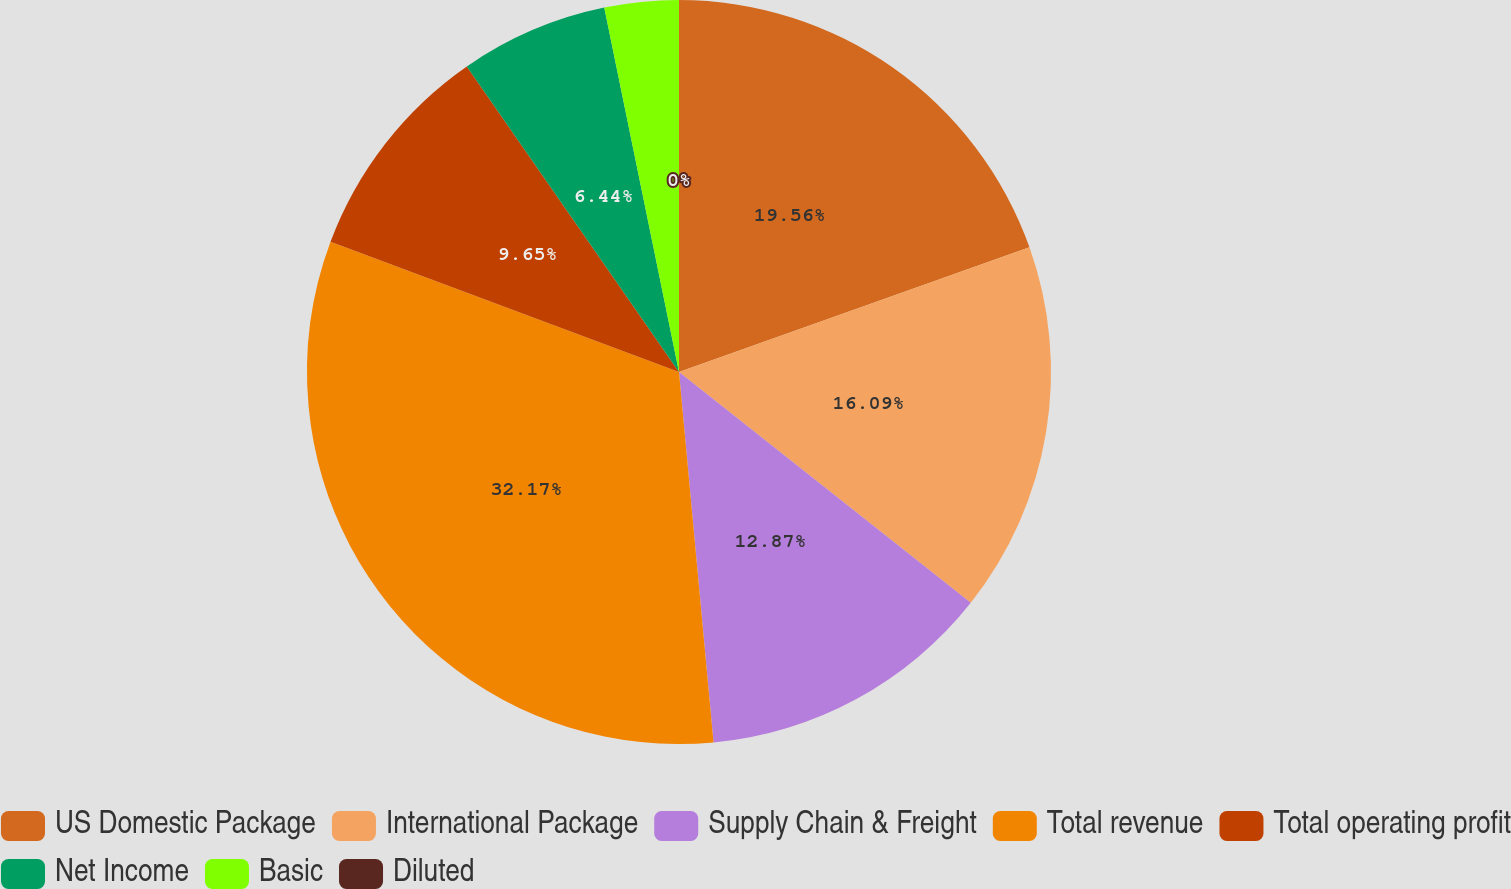Convert chart to OTSL. <chart><loc_0><loc_0><loc_500><loc_500><pie_chart><fcel>US Domestic Package<fcel>International Package<fcel>Supply Chain & Freight<fcel>Total revenue<fcel>Total operating profit<fcel>Net Income<fcel>Basic<fcel>Diluted<nl><fcel>19.56%<fcel>16.09%<fcel>12.87%<fcel>32.17%<fcel>9.65%<fcel>6.44%<fcel>3.22%<fcel>0.0%<nl></chart> 